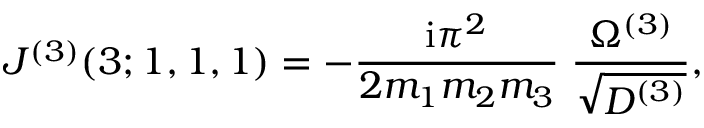Convert formula to latex. <formula><loc_0><loc_0><loc_500><loc_500>J ^ { ( 3 ) } ( 3 ; 1 , 1 , 1 ) = - \frac { i \pi ^ { 2 } } { 2 m _ { 1 } m _ { 2 } m _ { 3 } } \, \frac { \Omega ^ { ( 3 ) } } { \sqrt { D ^ { ( 3 ) } } } ,</formula> 